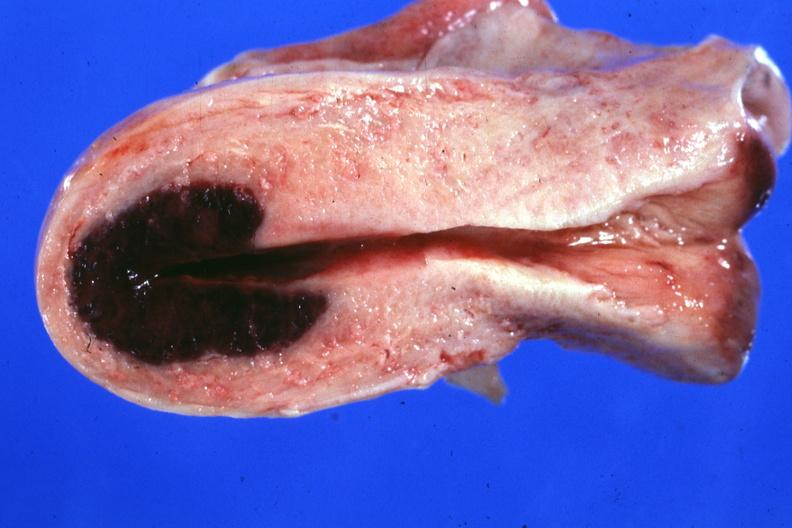s female reproductive present?
Answer the question using a single word or phrase. Yes 